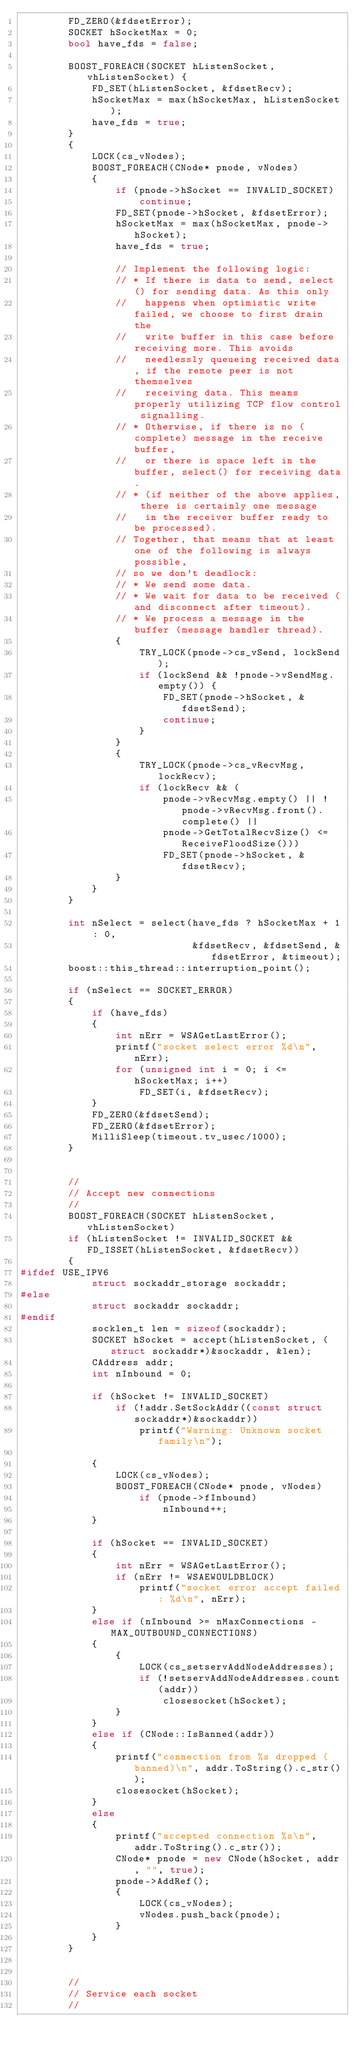Convert code to text. <code><loc_0><loc_0><loc_500><loc_500><_C++_>        FD_ZERO(&fdsetError);
        SOCKET hSocketMax = 0;
        bool have_fds = false;

        BOOST_FOREACH(SOCKET hListenSocket, vhListenSocket) {
            FD_SET(hListenSocket, &fdsetRecv);
            hSocketMax = max(hSocketMax, hListenSocket);
            have_fds = true;
        }
        {
            LOCK(cs_vNodes);
            BOOST_FOREACH(CNode* pnode, vNodes)
            {
                if (pnode->hSocket == INVALID_SOCKET)
                    continue;
                FD_SET(pnode->hSocket, &fdsetError);
                hSocketMax = max(hSocketMax, pnode->hSocket);
                have_fds = true;

                // Implement the following logic:
                // * If there is data to send, select() for sending data. As this only
                //   happens when optimistic write failed, we choose to first drain the
                //   write buffer in this case before receiving more. This avoids
                //   needlessly queueing received data, if the remote peer is not themselves
                //   receiving data. This means properly utilizing TCP flow control signalling.
                // * Otherwise, if there is no (complete) message in the receive buffer,
                //   or there is space left in the buffer, select() for receiving data.
                // * (if neither of the above applies, there is certainly one message
                //   in the receiver buffer ready to be processed).
                // Together, that means that at least one of the following is always possible,
                // so we don't deadlock:
                // * We send some data.
                // * We wait for data to be received (and disconnect after timeout).
                // * We process a message in the buffer (message handler thread).
                {
                    TRY_LOCK(pnode->cs_vSend, lockSend);
                    if (lockSend && !pnode->vSendMsg.empty()) {
                        FD_SET(pnode->hSocket, &fdsetSend);
                        continue;
                    }
                }
                {
                    TRY_LOCK(pnode->cs_vRecvMsg, lockRecv);
                    if (lockRecv && (
                        pnode->vRecvMsg.empty() || !pnode->vRecvMsg.front().complete() ||
                        pnode->GetTotalRecvSize() <= ReceiveFloodSize()))
                        FD_SET(pnode->hSocket, &fdsetRecv);
                }
            }
        }

        int nSelect = select(have_fds ? hSocketMax + 1 : 0,
                             &fdsetRecv, &fdsetSend, &fdsetError, &timeout);
        boost::this_thread::interruption_point();

        if (nSelect == SOCKET_ERROR)
        {
            if (have_fds)
            {
                int nErr = WSAGetLastError();
                printf("socket select error %d\n", nErr);
                for (unsigned int i = 0; i <= hSocketMax; i++)
                    FD_SET(i, &fdsetRecv);
            }
            FD_ZERO(&fdsetSend);
            FD_ZERO(&fdsetError);
            MilliSleep(timeout.tv_usec/1000);
        }


        //
        // Accept new connections
        //
        BOOST_FOREACH(SOCKET hListenSocket, vhListenSocket)
        if (hListenSocket != INVALID_SOCKET && FD_ISSET(hListenSocket, &fdsetRecv))
        {
#ifdef USE_IPV6
            struct sockaddr_storage sockaddr;
#else
            struct sockaddr sockaddr;
#endif
            socklen_t len = sizeof(sockaddr);
            SOCKET hSocket = accept(hListenSocket, (struct sockaddr*)&sockaddr, &len);
            CAddress addr;
            int nInbound = 0;

            if (hSocket != INVALID_SOCKET)
                if (!addr.SetSockAddr((const struct sockaddr*)&sockaddr))
                    printf("Warning: Unknown socket family\n");

            {
                LOCK(cs_vNodes);
                BOOST_FOREACH(CNode* pnode, vNodes)
                    if (pnode->fInbound)
                        nInbound++;
            }

            if (hSocket == INVALID_SOCKET)
            {
                int nErr = WSAGetLastError();
                if (nErr != WSAEWOULDBLOCK)
                    printf("socket error accept failed: %d\n", nErr);
            }
            else if (nInbound >= nMaxConnections - MAX_OUTBOUND_CONNECTIONS)
            {
                {
                    LOCK(cs_setservAddNodeAddresses);
                    if (!setservAddNodeAddresses.count(addr))
                        closesocket(hSocket);
                }
            }
            else if (CNode::IsBanned(addr))
            {
                printf("connection from %s dropped (banned)\n", addr.ToString().c_str());
                closesocket(hSocket);
            }
            else
            {
                printf("accepted connection %s\n", addr.ToString().c_str());
                CNode* pnode = new CNode(hSocket, addr, "", true);
                pnode->AddRef();
                {
                    LOCK(cs_vNodes);
                    vNodes.push_back(pnode);
                }
            }
        }


        //
        // Service each socket
        //</code> 